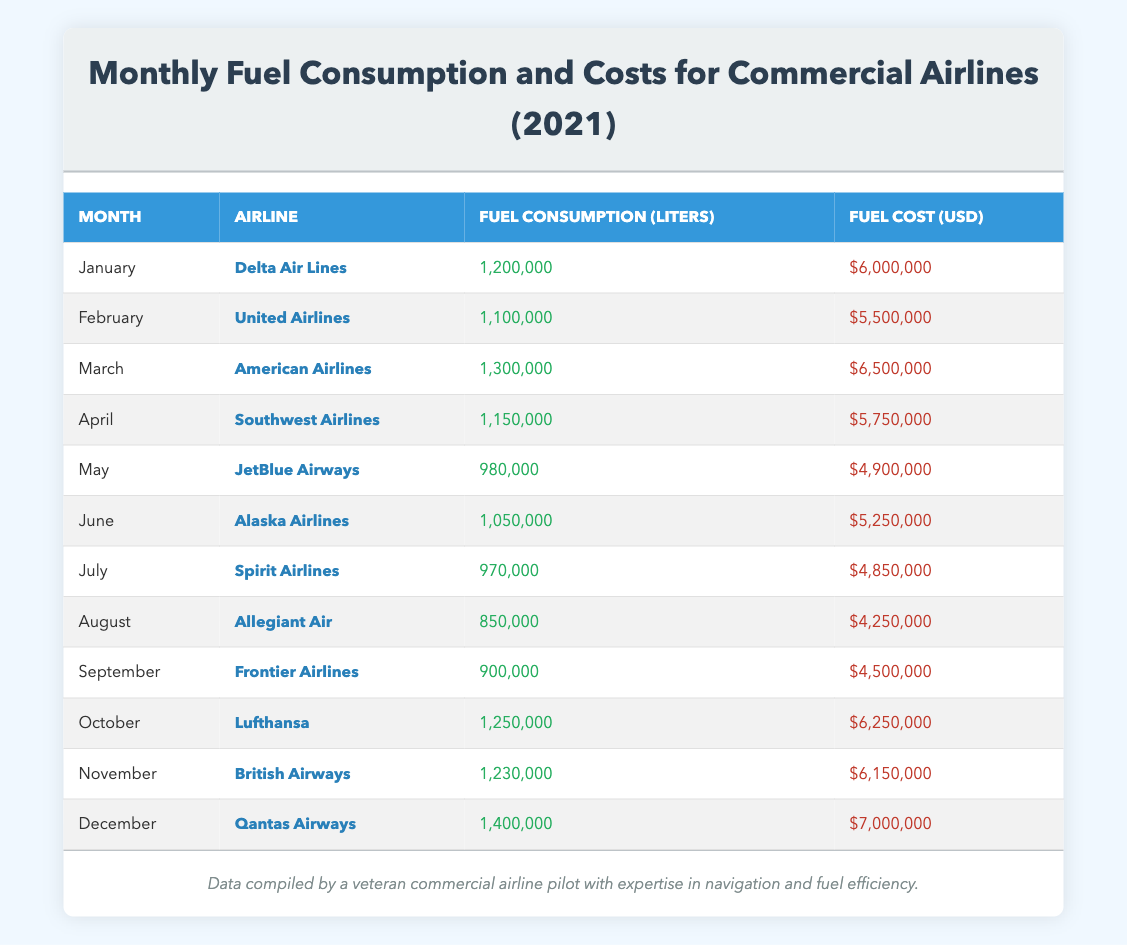What was the fuel cost for Delta Air Lines in January? The table lists "Delta Air Lines" under January with a fuel cost of $6,000,000.
Answer: $6,000,000 Which airline consumed the least fuel in 2021? The airlines listed are sorted by month, and by reviewing their fuel consumption, "Allegiant Air" consumed the least fuel at 850,000 liters in August.
Answer: Allegiant Air What is the total fuel consumption for Q2 (April to June) in liters? April (1,150,000 liters) + May (980,000 liters) + June (1,050,000 liters) = 3,180,000 liters in total for Q2.
Answer: 3,180,000 liters Was the fuel cost for American Airlines in March higher than that for United Airlines in February? American Airlines fuel cost is $6,500,000 in March, and United Airlines is $5,500,000 in February. Since $6,500,000 is greater than $5,500,000, the answer is yes.
Answer: Yes What is the average fuel cost per month across all airlines for 2021? The total fuel cost is $6,000,000 + $5,500,000 + $6,500,000 + $5,750,000 + $4,900,000 + $5,250,000 + $4,850,000 + $4,250,000 + $4,500,000 + $6,250,000 + $6,150,000 + $7,000,000 = $68,500,000. Dividing $68,500,000 by 12 months gives the average of approximately $5,708,333.33 or $5,708,333 (rounded to whole numbers).
Answer: $5,708,333 Which month had the highest fuel consumption and what was the value? Scanning the fuel consumption values, "December" has the highest at 1,400,000 liters for Qantas Airways.
Answer: 1,400,000 liters Is the fuel consumption in October lower than that in November? October has a fuel consumption of 1,250,000 liters, while November's is 1,230,000 liters. Since 1,250,000 is higher, the answer is no.
Answer: No What is the difference in fuel consumption between the months with the highest and lowest consumption? The highest consumption is in December (1,400,000 liters) and the lowest is in August (850,000 liters). The difference is 1,400,000 - 850,000 = 550,000 liters.
Answer: 550,000 liters During which month did JetBlue Airways have a fuel cost lower than $5 million? JetBlue Airways had a fuel cost of $4,900,000 in May, which is lower than $5 million. The answer reflects that May is the month where this occurs.
Answer: May 